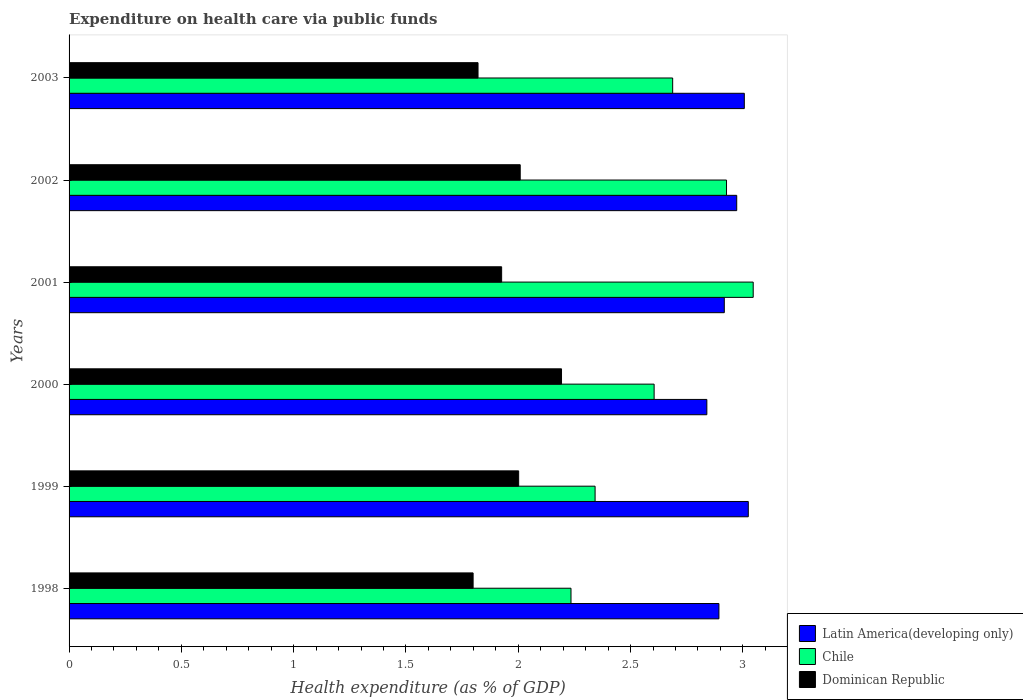How many groups of bars are there?
Ensure brevity in your answer.  6. Are the number of bars per tick equal to the number of legend labels?
Ensure brevity in your answer.  Yes. Are the number of bars on each tick of the Y-axis equal?
Your answer should be compact. Yes. How many bars are there on the 1st tick from the top?
Keep it short and to the point. 3. How many bars are there on the 2nd tick from the bottom?
Keep it short and to the point. 3. What is the expenditure made on health care in Chile in 2000?
Your answer should be compact. 2.6. Across all years, what is the maximum expenditure made on health care in Chile?
Keep it short and to the point. 3.05. Across all years, what is the minimum expenditure made on health care in Latin America(developing only)?
Offer a terse response. 2.84. In which year was the expenditure made on health care in Chile maximum?
Give a very brief answer. 2001. What is the total expenditure made on health care in Chile in the graph?
Offer a very short reply. 15.84. What is the difference between the expenditure made on health care in Chile in 1999 and that in 2003?
Provide a succinct answer. -0.35. What is the difference between the expenditure made on health care in Latin America(developing only) in 1998 and the expenditure made on health care in Chile in 2001?
Offer a very short reply. -0.15. What is the average expenditure made on health care in Latin America(developing only) per year?
Give a very brief answer. 2.94. In the year 2003, what is the difference between the expenditure made on health care in Chile and expenditure made on health care in Dominican Republic?
Your answer should be compact. 0.87. In how many years, is the expenditure made on health care in Chile greater than 2.4 %?
Make the answer very short. 4. What is the ratio of the expenditure made on health care in Dominican Republic in 2000 to that in 2003?
Your response must be concise. 1.2. Is the difference between the expenditure made on health care in Chile in 1998 and 2000 greater than the difference between the expenditure made on health care in Dominican Republic in 1998 and 2000?
Your answer should be compact. Yes. What is the difference between the highest and the second highest expenditure made on health care in Latin America(developing only)?
Make the answer very short. 0.02. What is the difference between the highest and the lowest expenditure made on health care in Dominican Republic?
Your answer should be very brief. 0.39. In how many years, is the expenditure made on health care in Dominican Republic greater than the average expenditure made on health care in Dominican Republic taken over all years?
Your answer should be compact. 3. What does the 3rd bar from the top in 1999 represents?
Offer a very short reply. Latin America(developing only). What does the 3rd bar from the bottom in 2001 represents?
Offer a terse response. Dominican Republic. Is it the case that in every year, the sum of the expenditure made on health care in Dominican Republic and expenditure made on health care in Chile is greater than the expenditure made on health care in Latin America(developing only)?
Offer a terse response. Yes. How many years are there in the graph?
Ensure brevity in your answer.  6. What is the difference between two consecutive major ticks on the X-axis?
Make the answer very short. 0.5. Does the graph contain grids?
Ensure brevity in your answer.  No. Where does the legend appear in the graph?
Your answer should be compact. Bottom right. How many legend labels are there?
Offer a terse response. 3. What is the title of the graph?
Your answer should be very brief. Expenditure on health care via public funds. Does "Latin America(all income levels)" appear as one of the legend labels in the graph?
Give a very brief answer. No. What is the label or title of the X-axis?
Your answer should be very brief. Health expenditure (as % of GDP). What is the Health expenditure (as % of GDP) of Latin America(developing only) in 1998?
Offer a terse response. 2.89. What is the Health expenditure (as % of GDP) in Chile in 1998?
Provide a succinct answer. 2.23. What is the Health expenditure (as % of GDP) of Dominican Republic in 1998?
Keep it short and to the point. 1.8. What is the Health expenditure (as % of GDP) of Latin America(developing only) in 1999?
Your answer should be very brief. 3.02. What is the Health expenditure (as % of GDP) of Chile in 1999?
Give a very brief answer. 2.34. What is the Health expenditure (as % of GDP) in Dominican Republic in 1999?
Your response must be concise. 2. What is the Health expenditure (as % of GDP) of Latin America(developing only) in 2000?
Offer a terse response. 2.84. What is the Health expenditure (as % of GDP) of Chile in 2000?
Your answer should be compact. 2.6. What is the Health expenditure (as % of GDP) of Dominican Republic in 2000?
Give a very brief answer. 2.19. What is the Health expenditure (as % of GDP) of Latin America(developing only) in 2001?
Provide a succinct answer. 2.92. What is the Health expenditure (as % of GDP) in Chile in 2001?
Provide a short and direct response. 3.05. What is the Health expenditure (as % of GDP) of Dominican Republic in 2001?
Your answer should be compact. 1.93. What is the Health expenditure (as % of GDP) in Latin America(developing only) in 2002?
Keep it short and to the point. 2.97. What is the Health expenditure (as % of GDP) of Chile in 2002?
Offer a terse response. 2.93. What is the Health expenditure (as % of GDP) of Dominican Republic in 2002?
Keep it short and to the point. 2.01. What is the Health expenditure (as % of GDP) in Latin America(developing only) in 2003?
Ensure brevity in your answer.  3.01. What is the Health expenditure (as % of GDP) in Chile in 2003?
Make the answer very short. 2.69. What is the Health expenditure (as % of GDP) of Dominican Republic in 2003?
Provide a short and direct response. 1.82. Across all years, what is the maximum Health expenditure (as % of GDP) of Latin America(developing only)?
Your answer should be very brief. 3.02. Across all years, what is the maximum Health expenditure (as % of GDP) in Chile?
Ensure brevity in your answer.  3.05. Across all years, what is the maximum Health expenditure (as % of GDP) in Dominican Republic?
Make the answer very short. 2.19. Across all years, what is the minimum Health expenditure (as % of GDP) of Latin America(developing only)?
Your response must be concise. 2.84. Across all years, what is the minimum Health expenditure (as % of GDP) in Chile?
Offer a very short reply. 2.23. Across all years, what is the minimum Health expenditure (as % of GDP) in Dominican Republic?
Your answer should be very brief. 1.8. What is the total Health expenditure (as % of GDP) in Latin America(developing only) in the graph?
Your response must be concise. 17.65. What is the total Health expenditure (as % of GDP) of Chile in the graph?
Keep it short and to the point. 15.84. What is the total Health expenditure (as % of GDP) in Dominican Republic in the graph?
Your answer should be very brief. 11.75. What is the difference between the Health expenditure (as % of GDP) of Latin America(developing only) in 1998 and that in 1999?
Provide a succinct answer. -0.13. What is the difference between the Health expenditure (as % of GDP) in Chile in 1998 and that in 1999?
Give a very brief answer. -0.11. What is the difference between the Health expenditure (as % of GDP) of Dominican Republic in 1998 and that in 1999?
Your answer should be very brief. -0.2. What is the difference between the Health expenditure (as % of GDP) of Latin America(developing only) in 1998 and that in 2000?
Give a very brief answer. 0.05. What is the difference between the Health expenditure (as % of GDP) in Chile in 1998 and that in 2000?
Make the answer very short. -0.37. What is the difference between the Health expenditure (as % of GDP) in Dominican Republic in 1998 and that in 2000?
Provide a short and direct response. -0.39. What is the difference between the Health expenditure (as % of GDP) of Latin America(developing only) in 1998 and that in 2001?
Provide a succinct answer. -0.02. What is the difference between the Health expenditure (as % of GDP) of Chile in 1998 and that in 2001?
Offer a very short reply. -0.81. What is the difference between the Health expenditure (as % of GDP) in Dominican Republic in 1998 and that in 2001?
Your response must be concise. -0.13. What is the difference between the Health expenditure (as % of GDP) of Latin America(developing only) in 1998 and that in 2002?
Provide a succinct answer. -0.08. What is the difference between the Health expenditure (as % of GDP) of Chile in 1998 and that in 2002?
Your answer should be compact. -0.69. What is the difference between the Health expenditure (as % of GDP) in Dominican Republic in 1998 and that in 2002?
Provide a succinct answer. -0.21. What is the difference between the Health expenditure (as % of GDP) of Latin America(developing only) in 1998 and that in 2003?
Offer a terse response. -0.11. What is the difference between the Health expenditure (as % of GDP) in Chile in 1998 and that in 2003?
Give a very brief answer. -0.45. What is the difference between the Health expenditure (as % of GDP) of Dominican Republic in 1998 and that in 2003?
Your answer should be compact. -0.02. What is the difference between the Health expenditure (as % of GDP) in Latin America(developing only) in 1999 and that in 2000?
Your answer should be very brief. 0.18. What is the difference between the Health expenditure (as % of GDP) in Chile in 1999 and that in 2000?
Your answer should be compact. -0.26. What is the difference between the Health expenditure (as % of GDP) in Dominican Republic in 1999 and that in 2000?
Ensure brevity in your answer.  -0.19. What is the difference between the Health expenditure (as % of GDP) in Latin America(developing only) in 1999 and that in 2001?
Ensure brevity in your answer.  0.11. What is the difference between the Health expenditure (as % of GDP) of Chile in 1999 and that in 2001?
Ensure brevity in your answer.  -0.7. What is the difference between the Health expenditure (as % of GDP) of Dominican Republic in 1999 and that in 2001?
Provide a succinct answer. 0.08. What is the difference between the Health expenditure (as % of GDP) in Latin America(developing only) in 1999 and that in 2002?
Keep it short and to the point. 0.05. What is the difference between the Health expenditure (as % of GDP) in Chile in 1999 and that in 2002?
Ensure brevity in your answer.  -0.59. What is the difference between the Health expenditure (as % of GDP) in Dominican Republic in 1999 and that in 2002?
Your answer should be very brief. -0.01. What is the difference between the Health expenditure (as % of GDP) of Latin America(developing only) in 1999 and that in 2003?
Give a very brief answer. 0.02. What is the difference between the Health expenditure (as % of GDP) of Chile in 1999 and that in 2003?
Your answer should be very brief. -0.35. What is the difference between the Health expenditure (as % of GDP) in Dominican Republic in 1999 and that in 2003?
Ensure brevity in your answer.  0.18. What is the difference between the Health expenditure (as % of GDP) in Latin America(developing only) in 2000 and that in 2001?
Offer a terse response. -0.08. What is the difference between the Health expenditure (as % of GDP) of Chile in 2000 and that in 2001?
Your answer should be compact. -0.44. What is the difference between the Health expenditure (as % of GDP) in Dominican Republic in 2000 and that in 2001?
Offer a terse response. 0.27. What is the difference between the Health expenditure (as % of GDP) of Latin America(developing only) in 2000 and that in 2002?
Offer a very short reply. -0.13. What is the difference between the Health expenditure (as % of GDP) of Chile in 2000 and that in 2002?
Provide a short and direct response. -0.32. What is the difference between the Health expenditure (as % of GDP) in Dominican Republic in 2000 and that in 2002?
Provide a succinct answer. 0.18. What is the difference between the Health expenditure (as % of GDP) in Latin America(developing only) in 2000 and that in 2003?
Give a very brief answer. -0.17. What is the difference between the Health expenditure (as % of GDP) of Chile in 2000 and that in 2003?
Keep it short and to the point. -0.08. What is the difference between the Health expenditure (as % of GDP) in Dominican Republic in 2000 and that in 2003?
Your response must be concise. 0.37. What is the difference between the Health expenditure (as % of GDP) of Latin America(developing only) in 2001 and that in 2002?
Make the answer very short. -0.06. What is the difference between the Health expenditure (as % of GDP) of Chile in 2001 and that in 2002?
Your response must be concise. 0.12. What is the difference between the Health expenditure (as % of GDP) in Dominican Republic in 2001 and that in 2002?
Offer a very short reply. -0.08. What is the difference between the Health expenditure (as % of GDP) in Latin America(developing only) in 2001 and that in 2003?
Provide a short and direct response. -0.09. What is the difference between the Health expenditure (as % of GDP) of Chile in 2001 and that in 2003?
Provide a short and direct response. 0.36. What is the difference between the Health expenditure (as % of GDP) in Dominican Republic in 2001 and that in 2003?
Offer a very short reply. 0.11. What is the difference between the Health expenditure (as % of GDP) in Latin America(developing only) in 2002 and that in 2003?
Give a very brief answer. -0.03. What is the difference between the Health expenditure (as % of GDP) of Chile in 2002 and that in 2003?
Offer a terse response. 0.24. What is the difference between the Health expenditure (as % of GDP) in Dominican Republic in 2002 and that in 2003?
Keep it short and to the point. 0.19. What is the difference between the Health expenditure (as % of GDP) of Latin America(developing only) in 1998 and the Health expenditure (as % of GDP) of Chile in 1999?
Give a very brief answer. 0.55. What is the difference between the Health expenditure (as % of GDP) in Latin America(developing only) in 1998 and the Health expenditure (as % of GDP) in Dominican Republic in 1999?
Provide a short and direct response. 0.89. What is the difference between the Health expenditure (as % of GDP) of Chile in 1998 and the Health expenditure (as % of GDP) of Dominican Republic in 1999?
Your answer should be very brief. 0.23. What is the difference between the Health expenditure (as % of GDP) of Latin America(developing only) in 1998 and the Health expenditure (as % of GDP) of Chile in 2000?
Ensure brevity in your answer.  0.29. What is the difference between the Health expenditure (as % of GDP) in Latin America(developing only) in 1998 and the Health expenditure (as % of GDP) in Dominican Republic in 2000?
Give a very brief answer. 0.7. What is the difference between the Health expenditure (as % of GDP) in Chile in 1998 and the Health expenditure (as % of GDP) in Dominican Republic in 2000?
Provide a succinct answer. 0.04. What is the difference between the Health expenditure (as % of GDP) of Latin America(developing only) in 1998 and the Health expenditure (as % of GDP) of Chile in 2001?
Ensure brevity in your answer.  -0.15. What is the difference between the Health expenditure (as % of GDP) of Latin America(developing only) in 1998 and the Health expenditure (as % of GDP) of Dominican Republic in 2001?
Make the answer very short. 0.97. What is the difference between the Health expenditure (as % of GDP) of Chile in 1998 and the Health expenditure (as % of GDP) of Dominican Republic in 2001?
Offer a terse response. 0.31. What is the difference between the Health expenditure (as % of GDP) in Latin America(developing only) in 1998 and the Health expenditure (as % of GDP) in Chile in 2002?
Your answer should be very brief. -0.03. What is the difference between the Health expenditure (as % of GDP) in Latin America(developing only) in 1998 and the Health expenditure (as % of GDP) in Dominican Republic in 2002?
Offer a very short reply. 0.88. What is the difference between the Health expenditure (as % of GDP) of Chile in 1998 and the Health expenditure (as % of GDP) of Dominican Republic in 2002?
Offer a very short reply. 0.23. What is the difference between the Health expenditure (as % of GDP) of Latin America(developing only) in 1998 and the Health expenditure (as % of GDP) of Chile in 2003?
Make the answer very short. 0.21. What is the difference between the Health expenditure (as % of GDP) of Latin America(developing only) in 1998 and the Health expenditure (as % of GDP) of Dominican Republic in 2003?
Give a very brief answer. 1.07. What is the difference between the Health expenditure (as % of GDP) in Chile in 1998 and the Health expenditure (as % of GDP) in Dominican Republic in 2003?
Your response must be concise. 0.41. What is the difference between the Health expenditure (as % of GDP) in Latin America(developing only) in 1999 and the Health expenditure (as % of GDP) in Chile in 2000?
Make the answer very short. 0.42. What is the difference between the Health expenditure (as % of GDP) of Latin America(developing only) in 1999 and the Health expenditure (as % of GDP) of Dominican Republic in 2000?
Offer a terse response. 0.83. What is the difference between the Health expenditure (as % of GDP) of Chile in 1999 and the Health expenditure (as % of GDP) of Dominican Republic in 2000?
Your answer should be very brief. 0.15. What is the difference between the Health expenditure (as % of GDP) of Latin America(developing only) in 1999 and the Health expenditure (as % of GDP) of Chile in 2001?
Provide a succinct answer. -0.02. What is the difference between the Health expenditure (as % of GDP) of Latin America(developing only) in 1999 and the Health expenditure (as % of GDP) of Dominican Republic in 2001?
Keep it short and to the point. 1.1. What is the difference between the Health expenditure (as % of GDP) in Chile in 1999 and the Health expenditure (as % of GDP) in Dominican Republic in 2001?
Ensure brevity in your answer.  0.42. What is the difference between the Health expenditure (as % of GDP) in Latin America(developing only) in 1999 and the Health expenditure (as % of GDP) in Chile in 2002?
Your answer should be compact. 0.1. What is the difference between the Health expenditure (as % of GDP) in Latin America(developing only) in 1999 and the Health expenditure (as % of GDP) in Dominican Republic in 2002?
Offer a terse response. 1.02. What is the difference between the Health expenditure (as % of GDP) in Chile in 1999 and the Health expenditure (as % of GDP) in Dominican Republic in 2002?
Make the answer very short. 0.33. What is the difference between the Health expenditure (as % of GDP) of Latin America(developing only) in 1999 and the Health expenditure (as % of GDP) of Chile in 2003?
Provide a short and direct response. 0.34. What is the difference between the Health expenditure (as % of GDP) in Latin America(developing only) in 1999 and the Health expenditure (as % of GDP) in Dominican Republic in 2003?
Offer a very short reply. 1.2. What is the difference between the Health expenditure (as % of GDP) in Chile in 1999 and the Health expenditure (as % of GDP) in Dominican Republic in 2003?
Give a very brief answer. 0.52. What is the difference between the Health expenditure (as % of GDP) in Latin America(developing only) in 2000 and the Health expenditure (as % of GDP) in Chile in 2001?
Make the answer very short. -0.21. What is the difference between the Health expenditure (as % of GDP) of Latin America(developing only) in 2000 and the Health expenditure (as % of GDP) of Dominican Republic in 2001?
Offer a terse response. 0.91. What is the difference between the Health expenditure (as % of GDP) of Chile in 2000 and the Health expenditure (as % of GDP) of Dominican Republic in 2001?
Provide a short and direct response. 0.68. What is the difference between the Health expenditure (as % of GDP) in Latin America(developing only) in 2000 and the Health expenditure (as % of GDP) in Chile in 2002?
Ensure brevity in your answer.  -0.09. What is the difference between the Health expenditure (as % of GDP) in Latin America(developing only) in 2000 and the Health expenditure (as % of GDP) in Dominican Republic in 2002?
Keep it short and to the point. 0.83. What is the difference between the Health expenditure (as % of GDP) in Chile in 2000 and the Health expenditure (as % of GDP) in Dominican Republic in 2002?
Your response must be concise. 0.6. What is the difference between the Health expenditure (as % of GDP) of Latin America(developing only) in 2000 and the Health expenditure (as % of GDP) of Chile in 2003?
Give a very brief answer. 0.15. What is the difference between the Health expenditure (as % of GDP) in Latin America(developing only) in 2000 and the Health expenditure (as % of GDP) in Dominican Republic in 2003?
Your response must be concise. 1.02. What is the difference between the Health expenditure (as % of GDP) in Chile in 2000 and the Health expenditure (as % of GDP) in Dominican Republic in 2003?
Keep it short and to the point. 0.78. What is the difference between the Health expenditure (as % of GDP) of Latin America(developing only) in 2001 and the Health expenditure (as % of GDP) of Chile in 2002?
Keep it short and to the point. -0.01. What is the difference between the Health expenditure (as % of GDP) of Latin America(developing only) in 2001 and the Health expenditure (as % of GDP) of Dominican Republic in 2002?
Provide a short and direct response. 0.91. What is the difference between the Health expenditure (as % of GDP) in Chile in 2001 and the Health expenditure (as % of GDP) in Dominican Republic in 2002?
Your answer should be very brief. 1.04. What is the difference between the Health expenditure (as % of GDP) in Latin America(developing only) in 2001 and the Health expenditure (as % of GDP) in Chile in 2003?
Offer a terse response. 0.23. What is the difference between the Health expenditure (as % of GDP) in Latin America(developing only) in 2001 and the Health expenditure (as % of GDP) in Dominican Republic in 2003?
Your answer should be very brief. 1.1. What is the difference between the Health expenditure (as % of GDP) of Chile in 2001 and the Health expenditure (as % of GDP) of Dominican Republic in 2003?
Your response must be concise. 1.23. What is the difference between the Health expenditure (as % of GDP) of Latin America(developing only) in 2002 and the Health expenditure (as % of GDP) of Chile in 2003?
Provide a short and direct response. 0.29. What is the difference between the Health expenditure (as % of GDP) in Latin America(developing only) in 2002 and the Health expenditure (as % of GDP) in Dominican Republic in 2003?
Keep it short and to the point. 1.15. What is the difference between the Health expenditure (as % of GDP) in Chile in 2002 and the Health expenditure (as % of GDP) in Dominican Republic in 2003?
Your answer should be compact. 1.11. What is the average Health expenditure (as % of GDP) of Latin America(developing only) per year?
Give a very brief answer. 2.94. What is the average Health expenditure (as % of GDP) of Chile per year?
Your answer should be very brief. 2.64. What is the average Health expenditure (as % of GDP) in Dominican Republic per year?
Provide a succinct answer. 1.96. In the year 1998, what is the difference between the Health expenditure (as % of GDP) in Latin America(developing only) and Health expenditure (as % of GDP) in Chile?
Ensure brevity in your answer.  0.66. In the year 1998, what is the difference between the Health expenditure (as % of GDP) in Latin America(developing only) and Health expenditure (as % of GDP) in Dominican Republic?
Provide a succinct answer. 1.09. In the year 1998, what is the difference between the Health expenditure (as % of GDP) of Chile and Health expenditure (as % of GDP) of Dominican Republic?
Give a very brief answer. 0.44. In the year 1999, what is the difference between the Health expenditure (as % of GDP) in Latin America(developing only) and Health expenditure (as % of GDP) in Chile?
Ensure brevity in your answer.  0.68. In the year 1999, what is the difference between the Health expenditure (as % of GDP) in Latin America(developing only) and Health expenditure (as % of GDP) in Dominican Republic?
Provide a short and direct response. 1.02. In the year 1999, what is the difference between the Health expenditure (as % of GDP) in Chile and Health expenditure (as % of GDP) in Dominican Republic?
Offer a terse response. 0.34. In the year 2000, what is the difference between the Health expenditure (as % of GDP) of Latin America(developing only) and Health expenditure (as % of GDP) of Chile?
Provide a short and direct response. 0.23. In the year 2000, what is the difference between the Health expenditure (as % of GDP) of Latin America(developing only) and Health expenditure (as % of GDP) of Dominican Republic?
Provide a succinct answer. 0.65. In the year 2000, what is the difference between the Health expenditure (as % of GDP) in Chile and Health expenditure (as % of GDP) in Dominican Republic?
Provide a short and direct response. 0.41. In the year 2001, what is the difference between the Health expenditure (as % of GDP) of Latin America(developing only) and Health expenditure (as % of GDP) of Chile?
Provide a succinct answer. -0.13. In the year 2001, what is the difference between the Health expenditure (as % of GDP) in Latin America(developing only) and Health expenditure (as % of GDP) in Dominican Republic?
Give a very brief answer. 0.99. In the year 2001, what is the difference between the Health expenditure (as % of GDP) in Chile and Health expenditure (as % of GDP) in Dominican Republic?
Your answer should be compact. 1.12. In the year 2002, what is the difference between the Health expenditure (as % of GDP) of Latin America(developing only) and Health expenditure (as % of GDP) of Chile?
Offer a terse response. 0.05. In the year 2002, what is the difference between the Health expenditure (as % of GDP) of Latin America(developing only) and Health expenditure (as % of GDP) of Dominican Republic?
Ensure brevity in your answer.  0.96. In the year 2002, what is the difference between the Health expenditure (as % of GDP) in Chile and Health expenditure (as % of GDP) in Dominican Republic?
Keep it short and to the point. 0.92. In the year 2003, what is the difference between the Health expenditure (as % of GDP) in Latin America(developing only) and Health expenditure (as % of GDP) in Chile?
Ensure brevity in your answer.  0.32. In the year 2003, what is the difference between the Health expenditure (as % of GDP) in Latin America(developing only) and Health expenditure (as % of GDP) in Dominican Republic?
Offer a very short reply. 1.19. In the year 2003, what is the difference between the Health expenditure (as % of GDP) of Chile and Health expenditure (as % of GDP) of Dominican Republic?
Ensure brevity in your answer.  0.87. What is the ratio of the Health expenditure (as % of GDP) of Latin America(developing only) in 1998 to that in 1999?
Provide a short and direct response. 0.96. What is the ratio of the Health expenditure (as % of GDP) of Chile in 1998 to that in 1999?
Your answer should be compact. 0.95. What is the ratio of the Health expenditure (as % of GDP) of Dominican Republic in 1998 to that in 1999?
Ensure brevity in your answer.  0.9. What is the ratio of the Health expenditure (as % of GDP) of Latin America(developing only) in 1998 to that in 2000?
Keep it short and to the point. 1.02. What is the ratio of the Health expenditure (as % of GDP) of Chile in 1998 to that in 2000?
Your answer should be compact. 0.86. What is the ratio of the Health expenditure (as % of GDP) of Dominican Republic in 1998 to that in 2000?
Offer a very short reply. 0.82. What is the ratio of the Health expenditure (as % of GDP) in Latin America(developing only) in 1998 to that in 2001?
Keep it short and to the point. 0.99. What is the ratio of the Health expenditure (as % of GDP) in Chile in 1998 to that in 2001?
Ensure brevity in your answer.  0.73. What is the ratio of the Health expenditure (as % of GDP) in Dominican Republic in 1998 to that in 2001?
Your answer should be compact. 0.93. What is the ratio of the Health expenditure (as % of GDP) in Latin America(developing only) in 1998 to that in 2002?
Keep it short and to the point. 0.97. What is the ratio of the Health expenditure (as % of GDP) in Chile in 1998 to that in 2002?
Make the answer very short. 0.76. What is the ratio of the Health expenditure (as % of GDP) of Dominican Republic in 1998 to that in 2002?
Offer a very short reply. 0.9. What is the ratio of the Health expenditure (as % of GDP) in Latin America(developing only) in 1998 to that in 2003?
Offer a terse response. 0.96. What is the ratio of the Health expenditure (as % of GDP) of Chile in 1998 to that in 2003?
Give a very brief answer. 0.83. What is the ratio of the Health expenditure (as % of GDP) in Dominican Republic in 1998 to that in 2003?
Keep it short and to the point. 0.99. What is the ratio of the Health expenditure (as % of GDP) in Latin America(developing only) in 1999 to that in 2000?
Make the answer very short. 1.06. What is the ratio of the Health expenditure (as % of GDP) in Chile in 1999 to that in 2000?
Offer a terse response. 0.9. What is the ratio of the Health expenditure (as % of GDP) in Latin America(developing only) in 1999 to that in 2001?
Offer a very short reply. 1.04. What is the ratio of the Health expenditure (as % of GDP) of Chile in 1999 to that in 2001?
Provide a short and direct response. 0.77. What is the ratio of the Health expenditure (as % of GDP) in Dominican Republic in 1999 to that in 2001?
Your response must be concise. 1.04. What is the ratio of the Health expenditure (as % of GDP) in Latin America(developing only) in 1999 to that in 2002?
Your answer should be compact. 1.02. What is the ratio of the Health expenditure (as % of GDP) of Chile in 1999 to that in 2002?
Your answer should be compact. 0.8. What is the ratio of the Health expenditure (as % of GDP) of Dominican Republic in 1999 to that in 2002?
Provide a succinct answer. 1. What is the ratio of the Health expenditure (as % of GDP) in Latin America(developing only) in 1999 to that in 2003?
Your answer should be compact. 1.01. What is the ratio of the Health expenditure (as % of GDP) of Chile in 1999 to that in 2003?
Your answer should be compact. 0.87. What is the ratio of the Health expenditure (as % of GDP) of Dominican Republic in 1999 to that in 2003?
Ensure brevity in your answer.  1.1. What is the ratio of the Health expenditure (as % of GDP) in Latin America(developing only) in 2000 to that in 2001?
Give a very brief answer. 0.97. What is the ratio of the Health expenditure (as % of GDP) of Chile in 2000 to that in 2001?
Your answer should be very brief. 0.86. What is the ratio of the Health expenditure (as % of GDP) in Dominican Republic in 2000 to that in 2001?
Ensure brevity in your answer.  1.14. What is the ratio of the Health expenditure (as % of GDP) of Latin America(developing only) in 2000 to that in 2002?
Offer a terse response. 0.96. What is the ratio of the Health expenditure (as % of GDP) of Chile in 2000 to that in 2002?
Your response must be concise. 0.89. What is the ratio of the Health expenditure (as % of GDP) in Dominican Republic in 2000 to that in 2002?
Offer a very short reply. 1.09. What is the ratio of the Health expenditure (as % of GDP) of Latin America(developing only) in 2000 to that in 2003?
Make the answer very short. 0.94. What is the ratio of the Health expenditure (as % of GDP) in Chile in 2000 to that in 2003?
Make the answer very short. 0.97. What is the ratio of the Health expenditure (as % of GDP) in Dominican Republic in 2000 to that in 2003?
Provide a succinct answer. 1.2. What is the ratio of the Health expenditure (as % of GDP) in Latin America(developing only) in 2001 to that in 2002?
Provide a short and direct response. 0.98. What is the ratio of the Health expenditure (as % of GDP) in Chile in 2001 to that in 2002?
Your answer should be compact. 1.04. What is the ratio of the Health expenditure (as % of GDP) of Dominican Republic in 2001 to that in 2002?
Make the answer very short. 0.96. What is the ratio of the Health expenditure (as % of GDP) of Latin America(developing only) in 2001 to that in 2003?
Offer a very short reply. 0.97. What is the ratio of the Health expenditure (as % of GDP) of Chile in 2001 to that in 2003?
Provide a short and direct response. 1.13. What is the ratio of the Health expenditure (as % of GDP) of Dominican Republic in 2001 to that in 2003?
Keep it short and to the point. 1.06. What is the ratio of the Health expenditure (as % of GDP) of Latin America(developing only) in 2002 to that in 2003?
Your answer should be compact. 0.99. What is the ratio of the Health expenditure (as % of GDP) of Chile in 2002 to that in 2003?
Offer a terse response. 1.09. What is the ratio of the Health expenditure (as % of GDP) of Dominican Republic in 2002 to that in 2003?
Offer a terse response. 1.1. What is the difference between the highest and the second highest Health expenditure (as % of GDP) of Latin America(developing only)?
Give a very brief answer. 0.02. What is the difference between the highest and the second highest Health expenditure (as % of GDP) of Chile?
Keep it short and to the point. 0.12. What is the difference between the highest and the second highest Health expenditure (as % of GDP) in Dominican Republic?
Offer a very short reply. 0.18. What is the difference between the highest and the lowest Health expenditure (as % of GDP) in Latin America(developing only)?
Offer a very short reply. 0.18. What is the difference between the highest and the lowest Health expenditure (as % of GDP) of Chile?
Offer a terse response. 0.81. What is the difference between the highest and the lowest Health expenditure (as % of GDP) of Dominican Republic?
Ensure brevity in your answer.  0.39. 